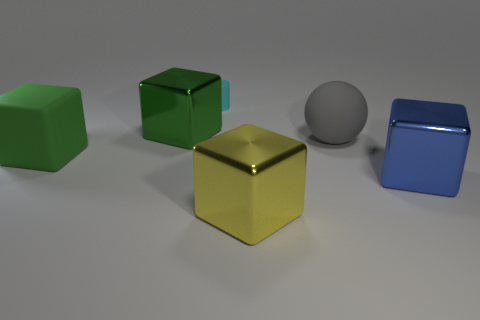What textures are present on the objects within the image, and can you describe their appearance? The objects exhibit a variety of textures. The large cube in the foreground has a glossy metallic finish, reflecting light and offering a smooth surface. The spherical object features a matte finish, absorbing light evenly and appearing soft. Each object's texture contributes to its appearance, giving it depth and character within the scene. 